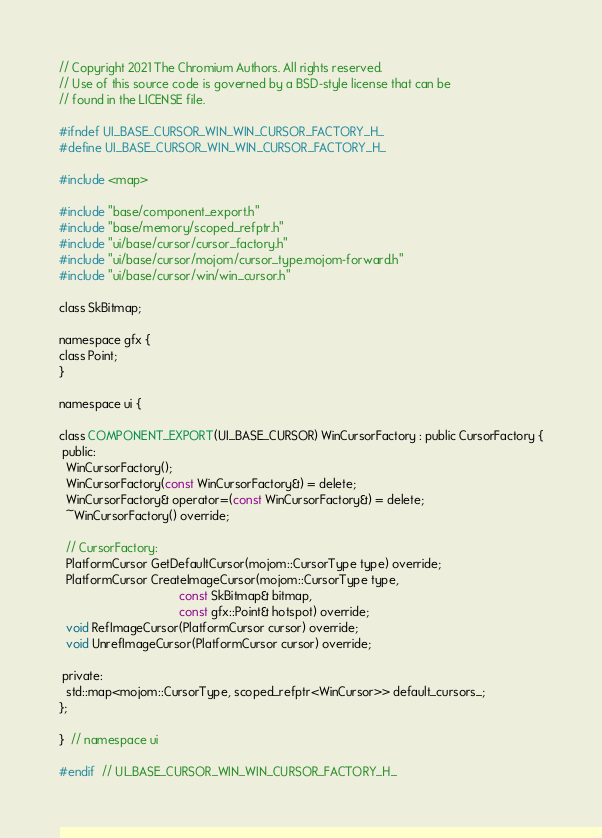<code> <loc_0><loc_0><loc_500><loc_500><_C_>// Copyright 2021 The Chromium Authors. All rights reserved.
// Use of this source code is governed by a BSD-style license that can be
// found in the LICENSE file.

#ifndef UI_BASE_CURSOR_WIN_WIN_CURSOR_FACTORY_H_
#define UI_BASE_CURSOR_WIN_WIN_CURSOR_FACTORY_H_

#include <map>

#include "base/component_export.h"
#include "base/memory/scoped_refptr.h"
#include "ui/base/cursor/cursor_factory.h"
#include "ui/base/cursor/mojom/cursor_type.mojom-forward.h"
#include "ui/base/cursor/win/win_cursor.h"

class SkBitmap;

namespace gfx {
class Point;
}

namespace ui {

class COMPONENT_EXPORT(UI_BASE_CURSOR) WinCursorFactory : public CursorFactory {
 public:
  WinCursorFactory();
  WinCursorFactory(const WinCursorFactory&) = delete;
  WinCursorFactory& operator=(const WinCursorFactory&) = delete;
  ~WinCursorFactory() override;

  // CursorFactory:
  PlatformCursor GetDefaultCursor(mojom::CursorType type) override;
  PlatformCursor CreateImageCursor(mojom::CursorType type,
                                   const SkBitmap& bitmap,
                                   const gfx::Point& hotspot) override;
  void RefImageCursor(PlatformCursor cursor) override;
  void UnrefImageCursor(PlatformCursor cursor) override;

 private:
  std::map<mojom::CursorType, scoped_refptr<WinCursor>> default_cursors_;
};

}  // namespace ui

#endif  // UI_BASE_CURSOR_WIN_WIN_CURSOR_FACTORY_H_
</code> 